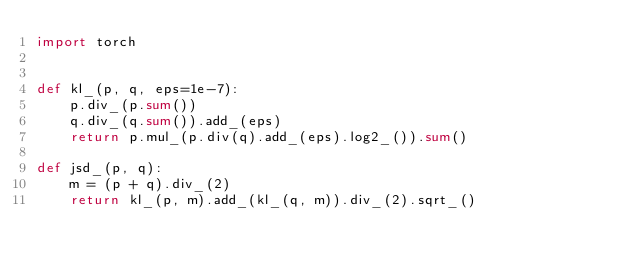<code> <loc_0><loc_0><loc_500><loc_500><_Python_>import torch


def kl_(p, q, eps=1e-7):
    p.div_(p.sum())
    q.div_(q.sum()).add_(eps)
    return p.mul_(p.div(q).add_(eps).log2_()).sum()

def jsd_(p, q):
    m = (p + q).div_(2)
    return kl_(p, m).add_(kl_(q, m)).div_(2).sqrt_()
</code> 